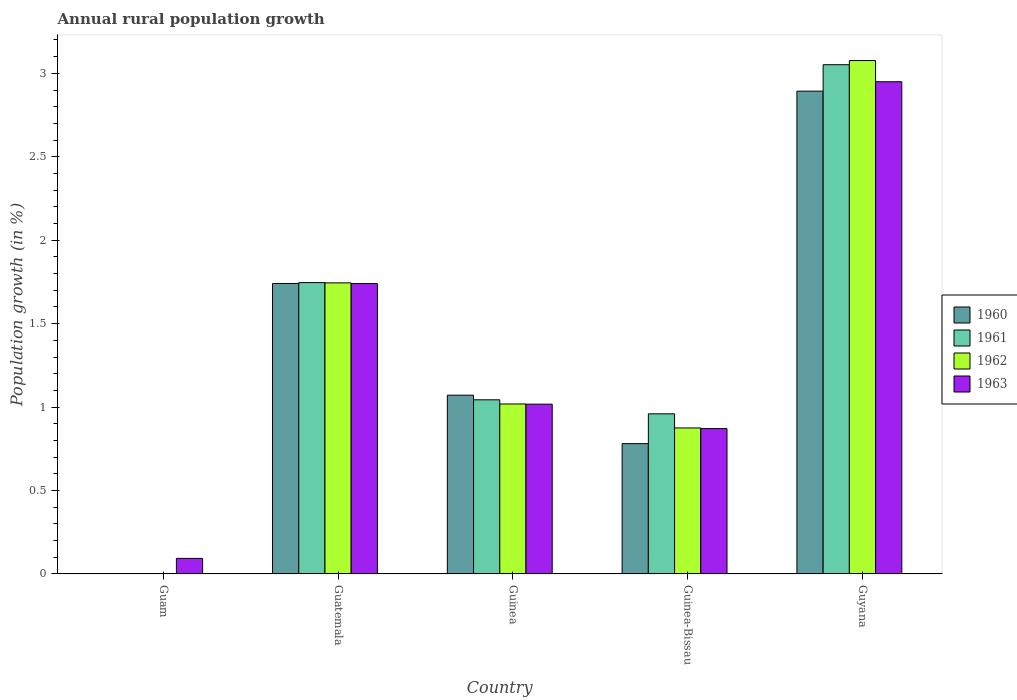How many different coloured bars are there?
Make the answer very short. 4. What is the label of the 5th group of bars from the left?
Your response must be concise. Guyana. In how many cases, is the number of bars for a given country not equal to the number of legend labels?
Provide a short and direct response. 1. What is the percentage of rural population growth in 1962 in Guatemala?
Your response must be concise. 1.74. Across all countries, what is the maximum percentage of rural population growth in 1963?
Provide a succinct answer. 2.95. Across all countries, what is the minimum percentage of rural population growth in 1961?
Your response must be concise. 0. In which country was the percentage of rural population growth in 1963 maximum?
Make the answer very short. Guyana. What is the total percentage of rural population growth in 1963 in the graph?
Give a very brief answer. 6.67. What is the difference between the percentage of rural population growth in 1963 in Guinea and that in Guinea-Bissau?
Offer a very short reply. 0.15. What is the difference between the percentage of rural population growth in 1962 in Guatemala and the percentage of rural population growth in 1961 in Guinea-Bissau?
Ensure brevity in your answer.  0.78. What is the average percentage of rural population growth in 1962 per country?
Provide a succinct answer. 1.34. What is the difference between the percentage of rural population growth of/in 1963 and percentage of rural population growth of/in 1962 in Guatemala?
Offer a very short reply. -0. In how many countries, is the percentage of rural population growth in 1962 greater than 0.2 %?
Ensure brevity in your answer.  4. What is the ratio of the percentage of rural population growth in 1962 in Guinea to that in Guinea-Bissau?
Provide a short and direct response. 1.16. Is the difference between the percentage of rural population growth in 1963 in Guinea-Bissau and Guyana greater than the difference between the percentage of rural population growth in 1962 in Guinea-Bissau and Guyana?
Your response must be concise. Yes. What is the difference between the highest and the second highest percentage of rural population growth in 1961?
Offer a terse response. -1.31. What is the difference between the highest and the lowest percentage of rural population growth in 1960?
Offer a terse response. 2.89. In how many countries, is the percentage of rural population growth in 1960 greater than the average percentage of rural population growth in 1960 taken over all countries?
Give a very brief answer. 2. Is the sum of the percentage of rural population growth in 1963 in Guam and Guatemala greater than the maximum percentage of rural population growth in 1962 across all countries?
Make the answer very short. No. Is it the case that in every country, the sum of the percentage of rural population growth in 1961 and percentage of rural population growth in 1963 is greater than the sum of percentage of rural population growth in 1962 and percentage of rural population growth in 1960?
Your answer should be compact. No. Is it the case that in every country, the sum of the percentage of rural population growth in 1962 and percentage of rural population growth in 1961 is greater than the percentage of rural population growth in 1963?
Offer a terse response. No. How many bars are there?
Your answer should be compact. 17. How many countries are there in the graph?
Provide a short and direct response. 5. What is the difference between two consecutive major ticks on the Y-axis?
Offer a terse response. 0.5. Are the values on the major ticks of Y-axis written in scientific E-notation?
Your answer should be compact. No. Does the graph contain grids?
Ensure brevity in your answer.  No. How many legend labels are there?
Make the answer very short. 4. How are the legend labels stacked?
Make the answer very short. Vertical. What is the title of the graph?
Make the answer very short. Annual rural population growth. Does "1976" appear as one of the legend labels in the graph?
Make the answer very short. No. What is the label or title of the X-axis?
Your answer should be very brief. Country. What is the label or title of the Y-axis?
Provide a short and direct response. Population growth (in %). What is the Population growth (in %) of 1961 in Guam?
Provide a succinct answer. 0. What is the Population growth (in %) of 1962 in Guam?
Provide a short and direct response. 0. What is the Population growth (in %) of 1963 in Guam?
Your answer should be compact. 0.09. What is the Population growth (in %) of 1960 in Guatemala?
Offer a very short reply. 1.74. What is the Population growth (in %) in 1961 in Guatemala?
Provide a succinct answer. 1.75. What is the Population growth (in %) in 1962 in Guatemala?
Your response must be concise. 1.74. What is the Population growth (in %) in 1963 in Guatemala?
Offer a very short reply. 1.74. What is the Population growth (in %) of 1960 in Guinea?
Your answer should be compact. 1.07. What is the Population growth (in %) of 1961 in Guinea?
Offer a terse response. 1.04. What is the Population growth (in %) in 1962 in Guinea?
Your answer should be compact. 1.02. What is the Population growth (in %) of 1963 in Guinea?
Ensure brevity in your answer.  1.02. What is the Population growth (in %) of 1960 in Guinea-Bissau?
Your response must be concise. 0.78. What is the Population growth (in %) of 1961 in Guinea-Bissau?
Provide a short and direct response. 0.96. What is the Population growth (in %) of 1962 in Guinea-Bissau?
Offer a terse response. 0.88. What is the Population growth (in %) of 1963 in Guinea-Bissau?
Give a very brief answer. 0.87. What is the Population growth (in %) of 1960 in Guyana?
Ensure brevity in your answer.  2.89. What is the Population growth (in %) in 1961 in Guyana?
Make the answer very short. 3.05. What is the Population growth (in %) in 1962 in Guyana?
Keep it short and to the point. 3.08. What is the Population growth (in %) in 1963 in Guyana?
Your response must be concise. 2.95. Across all countries, what is the maximum Population growth (in %) in 1960?
Keep it short and to the point. 2.89. Across all countries, what is the maximum Population growth (in %) of 1961?
Provide a short and direct response. 3.05. Across all countries, what is the maximum Population growth (in %) of 1962?
Your answer should be very brief. 3.08. Across all countries, what is the maximum Population growth (in %) of 1963?
Your answer should be very brief. 2.95. Across all countries, what is the minimum Population growth (in %) in 1960?
Provide a succinct answer. 0. Across all countries, what is the minimum Population growth (in %) in 1961?
Provide a succinct answer. 0. Across all countries, what is the minimum Population growth (in %) in 1963?
Offer a very short reply. 0.09. What is the total Population growth (in %) in 1960 in the graph?
Keep it short and to the point. 6.49. What is the total Population growth (in %) of 1961 in the graph?
Provide a short and direct response. 6.8. What is the total Population growth (in %) of 1962 in the graph?
Your answer should be compact. 6.71. What is the total Population growth (in %) in 1963 in the graph?
Provide a succinct answer. 6.67. What is the difference between the Population growth (in %) of 1963 in Guam and that in Guatemala?
Your answer should be compact. -1.65. What is the difference between the Population growth (in %) in 1963 in Guam and that in Guinea?
Offer a very short reply. -0.92. What is the difference between the Population growth (in %) in 1963 in Guam and that in Guinea-Bissau?
Offer a very short reply. -0.78. What is the difference between the Population growth (in %) of 1963 in Guam and that in Guyana?
Give a very brief answer. -2.86. What is the difference between the Population growth (in %) in 1960 in Guatemala and that in Guinea?
Keep it short and to the point. 0.67. What is the difference between the Population growth (in %) of 1961 in Guatemala and that in Guinea?
Offer a very short reply. 0.7. What is the difference between the Population growth (in %) of 1962 in Guatemala and that in Guinea?
Offer a terse response. 0.73. What is the difference between the Population growth (in %) in 1963 in Guatemala and that in Guinea?
Ensure brevity in your answer.  0.72. What is the difference between the Population growth (in %) of 1960 in Guatemala and that in Guinea-Bissau?
Your answer should be compact. 0.96. What is the difference between the Population growth (in %) of 1961 in Guatemala and that in Guinea-Bissau?
Provide a succinct answer. 0.79. What is the difference between the Population growth (in %) in 1962 in Guatemala and that in Guinea-Bissau?
Your response must be concise. 0.87. What is the difference between the Population growth (in %) in 1963 in Guatemala and that in Guinea-Bissau?
Offer a terse response. 0.87. What is the difference between the Population growth (in %) in 1960 in Guatemala and that in Guyana?
Provide a succinct answer. -1.15. What is the difference between the Population growth (in %) of 1961 in Guatemala and that in Guyana?
Keep it short and to the point. -1.31. What is the difference between the Population growth (in %) of 1962 in Guatemala and that in Guyana?
Provide a short and direct response. -1.33. What is the difference between the Population growth (in %) in 1963 in Guatemala and that in Guyana?
Give a very brief answer. -1.21. What is the difference between the Population growth (in %) of 1960 in Guinea and that in Guinea-Bissau?
Offer a terse response. 0.29. What is the difference between the Population growth (in %) in 1961 in Guinea and that in Guinea-Bissau?
Give a very brief answer. 0.08. What is the difference between the Population growth (in %) of 1962 in Guinea and that in Guinea-Bissau?
Keep it short and to the point. 0.14. What is the difference between the Population growth (in %) of 1963 in Guinea and that in Guinea-Bissau?
Provide a succinct answer. 0.15. What is the difference between the Population growth (in %) in 1960 in Guinea and that in Guyana?
Provide a short and direct response. -1.82. What is the difference between the Population growth (in %) in 1961 in Guinea and that in Guyana?
Your answer should be compact. -2.01. What is the difference between the Population growth (in %) of 1962 in Guinea and that in Guyana?
Offer a terse response. -2.06. What is the difference between the Population growth (in %) in 1963 in Guinea and that in Guyana?
Your answer should be compact. -1.93. What is the difference between the Population growth (in %) in 1960 in Guinea-Bissau and that in Guyana?
Provide a succinct answer. -2.11. What is the difference between the Population growth (in %) of 1961 in Guinea-Bissau and that in Guyana?
Offer a terse response. -2.09. What is the difference between the Population growth (in %) in 1962 in Guinea-Bissau and that in Guyana?
Your response must be concise. -2.2. What is the difference between the Population growth (in %) of 1963 in Guinea-Bissau and that in Guyana?
Offer a terse response. -2.08. What is the difference between the Population growth (in %) in 1960 in Guatemala and the Population growth (in %) in 1961 in Guinea?
Keep it short and to the point. 0.7. What is the difference between the Population growth (in %) of 1960 in Guatemala and the Population growth (in %) of 1962 in Guinea?
Provide a succinct answer. 0.72. What is the difference between the Population growth (in %) in 1960 in Guatemala and the Population growth (in %) in 1963 in Guinea?
Make the answer very short. 0.72. What is the difference between the Population growth (in %) in 1961 in Guatemala and the Population growth (in %) in 1962 in Guinea?
Your answer should be very brief. 0.73. What is the difference between the Population growth (in %) in 1961 in Guatemala and the Population growth (in %) in 1963 in Guinea?
Offer a terse response. 0.73. What is the difference between the Population growth (in %) of 1962 in Guatemala and the Population growth (in %) of 1963 in Guinea?
Your answer should be very brief. 0.73. What is the difference between the Population growth (in %) in 1960 in Guatemala and the Population growth (in %) in 1961 in Guinea-Bissau?
Offer a very short reply. 0.78. What is the difference between the Population growth (in %) in 1960 in Guatemala and the Population growth (in %) in 1962 in Guinea-Bissau?
Offer a very short reply. 0.87. What is the difference between the Population growth (in %) of 1960 in Guatemala and the Population growth (in %) of 1963 in Guinea-Bissau?
Offer a very short reply. 0.87. What is the difference between the Population growth (in %) of 1961 in Guatemala and the Population growth (in %) of 1962 in Guinea-Bissau?
Provide a short and direct response. 0.87. What is the difference between the Population growth (in %) in 1961 in Guatemala and the Population growth (in %) in 1963 in Guinea-Bissau?
Offer a very short reply. 0.87. What is the difference between the Population growth (in %) in 1962 in Guatemala and the Population growth (in %) in 1963 in Guinea-Bissau?
Offer a terse response. 0.87. What is the difference between the Population growth (in %) in 1960 in Guatemala and the Population growth (in %) in 1961 in Guyana?
Offer a very short reply. -1.31. What is the difference between the Population growth (in %) in 1960 in Guatemala and the Population growth (in %) in 1962 in Guyana?
Offer a terse response. -1.34. What is the difference between the Population growth (in %) of 1960 in Guatemala and the Population growth (in %) of 1963 in Guyana?
Provide a succinct answer. -1.21. What is the difference between the Population growth (in %) in 1961 in Guatemala and the Population growth (in %) in 1962 in Guyana?
Your answer should be compact. -1.33. What is the difference between the Population growth (in %) in 1961 in Guatemala and the Population growth (in %) in 1963 in Guyana?
Give a very brief answer. -1.2. What is the difference between the Population growth (in %) of 1962 in Guatemala and the Population growth (in %) of 1963 in Guyana?
Provide a short and direct response. -1.21. What is the difference between the Population growth (in %) of 1960 in Guinea and the Population growth (in %) of 1961 in Guinea-Bissau?
Your answer should be compact. 0.11. What is the difference between the Population growth (in %) of 1960 in Guinea and the Population growth (in %) of 1962 in Guinea-Bissau?
Your answer should be very brief. 0.2. What is the difference between the Population growth (in %) of 1960 in Guinea and the Population growth (in %) of 1963 in Guinea-Bissau?
Offer a terse response. 0.2. What is the difference between the Population growth (in %) of 1961 in Guinea and the Population growth (in %) of 1962 in Guinea-Bissau?
Your response must be concise. 0.17. What is the difference between the Population growth (in %) in 1961 in Guinea and the Population growth (in %) in 1963 in Guinea-Bissau?
Provide a succinct answer. 0.17. What is the difference between the Population growth (in %) in 1962 in Guinea and the Population growth (in %) in 1963 in Guinea-Bissau?
Provide a succinct answer. 0.15. What is the difference between the Population growth (in %) of 1960 in Guinea and the Population growth (in %) of 1961 in Guyana?
Offer a very short reply. -1.98. What is the difference between the Population growth (in %) of 1960 in Guinea and the Population growth (in %) of 1962 in Guyana?
Ensure brevity in your answer.  -2.01. What is the difference between the Population growth (in %) of 1960 in Guinea and the Population growth (in %) of 1963 in Guyana?
Make the answer very short. -1.88. What is the difference between the Population growth (in %) in 1961 in Guinea and the Population growth (in %) in 1962 in Guyana?
Your response must be concise. -2.03. What is the difference between the Population growth (in %) of 1961 in Guinea and the Population growth (in %) of 1963 in Guyana?
Your answer should be compact. -1.91. What is the difference between the Population growth (in %) in 1962 in Guinea and the Population growth (in %) in 1963 in Guyana?
Provide a short and direct response. -1.93. What is the difference between the Population growth (in %) in 1960 in Guinea-Bissau and the Population growth (in %) in 1961 in Guyana?
Keep it short and to the point. -2.27. What is the difference between the Population growth (in %) in 1960 in Guinea-Bissau and the Population growth (in %) in 1962 in Guyana?
Offer a very short reply. -2.3. What is the difference between the Population growth (in %) of 1960 in Guinea-Bissau and the Population growth (in %) of 1963 in Guyana?
Provide a short and direct response. -2.17. What is the difference between the Population growth (in %) of 1961 in Guinea-Bissau and the Population growth (in %) of 1962 in Guyana?
Make the answer very short. -2.12. What is the difference between the Population growth (in %) of 1961 in Guinea-Bissau and the Population growth (in %) of 1963 in Guyana?
Your answer should be compact. -1.99. What is the difference between the Population growth (in %) in 1962 in Guinea-Bissau and the Population growth (in %) in 1963 in Guyana?
Ensure brevity in your answer.  -2.07. What is the average Population growth (in %) of 1960 per country?
Keep it short and to the point. 1.3. What is the average Population growth (in %) of 1961 per country?
Keep it short and to the point. 1.36. What is the average Population growth (in %) in 1962 per country?
Give a very brief answer. 1.34. What is the average Population growth (in %) in 1963 per country?
Your response must be concise. 1.33. What is the difference between the Population growth (in %) in 1960 and Population growth (in %) in 1961 in Guatemala?
Make the answer very short. -0.01. What is the difference between the Population growth (in %) in 1960 and Population growth (in %) in 1962 in Guatemala?
Your answer should be compact. -0. What is the difference between the Population growth (in %) of 1960 and Population growth (in %) of 1963 in Guatemala?
Give a very brief answer. 0. What is the difference between the Population growth (in %) of 1961 and Population growth (in %) of 1962 in Guatemala?
Your answer should be very brief. 0. What is the difference between the Population growth (in %) in 1961 and Population growth (in %) in 1963 in Guatemala?
Your answer should be compact. 0.01. What is the difference between the Population growth (in %) of 1962 and Population growth (in %) of 1963 in Guatemala?
Offer a very short reply. 0. What is the difference between the Population growth (in %) in 1960 and Population growth (in %) in 1961 in Guinea?
Offer a very short reply. 0.03. What is the difference between the Population growth (in %) of 1960 and Population growth (in %) of 1962 in Guinea?
Provide a short and direct response. 0.05. What is the difference between the Population growth (in %) of 1960 and Population growth (in %) of 1963 in Guinea?
Ensure brevity in your answer.  0.05. What is the difference between the Population growth (in %) in 1961 and Population growth (in %) in 1962 in Guinea?
Ensure brevity in your answer.  0.03. What is the difference between the Population growth (in %) in 1961 and Population growth (in %) in 1963 in Guinea?
Ensure brevity in your answer.  0.03. What is the difference between the Population growth (in %) in 1962 and Population growth (in %) in 1963 in Guinea?
Keep it short and to the point. 0. What is the difference between the Population growth (in %) of 1960 and Population growth (in %) of 1961 in Guinea-Bissau?
Offer a terse response. -0.18. What is the difference between the Population growth (in %) of 1960 and Population growth (in %) of 1962 in Guinea-Bissau?
Offer a terse response. -0.09. What is the difference between the Population growth (in %) in 1960 and Population growth (in %) in 1963 in Guinea-Bissau?
Provide a short and direct response. -0.09. What is the difference between the Population growth (in %) in 1961 and Population growth (in %) in 1962 in Guinea-Bissau?
Keep it short and to the point. 0.08. What is the difference between the Population growth (in %) in 1961 and Population growth (in %) in 1963 in Guinea-Bissau?
Make the answer very short. 0.09. What is the difference between the Population growth (in %) in 1962 and Population growth (in %) in 1963 in Guinea-Bissau?
Make the answer very short. 0. What is the difference between the Population growth (in %) in 1960 and Population growth (in %) in 1961 in Guyana?
Ensure brevity in your answer.  -0.16. What is the difference between the Population growth (in %) of 1960 and Population growth (in %) of 1962 in Guyana?
Ensure brevity in your answer.  -0.18. What is the difference between the Population growth (in %) of 1960 and Population growth (in %) of 1963 in Guyana?
Make the answer very short. -0.06. What is the difference between the Population growth (in %) of 1961 and Population growth (in %) of 1962 in Guyana?
Your answer should be very brief. -0.03. What is the difference between the Population growth (in %) in 1961 and Population growth (in %) in 1963 in Guyana?
Your answer should be compact. 0.1. What is the difference between the Population growth (in %) in 1962 and Population growth (in %) in 1963 in Guyana?
Make the answer very short. 0.13. What is the ratio of the Population growth (in %) of 1963 in Guam to that in Guatemala?
Provide a succinct answer. 0.05. What is the ratio of the Population growth (in %) of 1963 in Guam to that in Guinea?
Offer a very short reply. 0.09. What is the ratio of the Population growth (in %) of 1963 in Guam to that in Guinea-Bissau?
Provide a short and direct response. 0.11. What is the ratio of the Population growth (in %) of 1963 in Guam to that in Guyana?
Give a very brief answer. 0.03. What is the ratio of the Population growth (in %) in 1960 in Guatemala to that in Guinea?
Your answer should be compact. 1.62. What is the ratio of the Population growth (in %) of 1961 in Guatemala to that in Guinea?
Your answer should be compact. 1.67. What is the ratio of the Population growth (in %) of 1962 in Guatemala to that in Guinea?
Make the answer very short. 1.71. What is the ratio of the Population growth (in %) in 1963 in Guatemala to that in Guinea?
Your answer should be very brief. 1.71. What is the ratio of the Population growth (in %) in 1960 in Guatemala to that in Guinea-Bissau?
Ensure brevity in your answer.  2.23. What is the ratio of the Population growth (in %) in 1961 in Guatemala to that in Guinea-Bissau?
Your answer should be very brief. 1.82. What is the ratio of the Population growth (in %) in 1962 in Guatemala to that in Guinea-Bissau?
Give a very brief answer. 1.99. What is the ratio of the Population growth (in %) in 1963 in Guatemala to that in Guinea-Bissau?
Ensure brevity in your answer.  2. What is the ratio of the Population growth (in %) of 1960 in Guatemala to that in Guyana?
Your response must be concise. 0.6. What is the ratio of the Population growth (in %) of 1961 in Guatemala to that in Guyana?
Your response must be concise. 0.57. What is the ratio of the Population growth (in %) of 1962 in Guatemala to that in Guyana?
Your answer should be very brief. 0.57. What is the ratio of the Population growth (in %) in 1963 in Guatemala to that in Guyana?
Offer a very short reply. 0.59. What is the ratio of the Population growth (in %) in 1960 in Guinea to that in Guinea-Bissau?
Provide a succinct answer. 1.37. What is the ratio of the Population growth (in %) of 1961 in Guinea to that in Guinea-Bissau?
Your answer should be very brief. 1.09. What is the ratio of the Population growth (in %) in 1962 in Guinea to that in Guinea-Bissau?
Ensure brevity in your answer.  1.16. What is the ratio of the Population growth (in %) in 1963 in Guinea to that in Guinea-Bissau?
Provide a short and direct response. 1.17. What is the ratio of the Population growth (in %) of 1960 in Guinea to that in Guyana?
Your answer should be compact. 0.37. What is the ratio of the Population growth (in %) in 1961 in Guinea to that in Guyana?
Your answer should be very brief. 0.34. What is the ratio of the Population growth (in %) in 1962 in Guinea to that in Guyana?
Your answer should be compact. 0.33. What is the ratio of the Population growth (in %) in 1963 in Guinea to that in Guyana?
Give a very brief answer. 0.34. What is the ratio of the Population growth (in %) in 1960 in Guinea-Bissau to that in Guyana?
Provide a short and direct response. 0.27. What is the ratio of the Population growth (in %) of 1961 in Guinea-Bissau to that in Guyana?
Your response must be concise. 0.31. What is the ratio of the Population growth (in %) in 1962 in Guinea-Bissau to that in Guyana?
Make the answer very short. 0.28. What is the ratio of the Population growth (in %) in 1963 in Guinea-Bissau to that in Guyana?
Keep it short and to the point. 0.3. What is the difference between the highest and the second highest Population growth (in %) in 1960?
Offer a very short reply. 1.15. What is the difference between the highest and the second highest Population growth (in %) of 1961?
Offer a very short reply. 1.31. What is the difference between the highest and the second highest Population growth (in %) of 1962?
Your answer should be compact. 1.33. What is the difference between the highest and the second highest Population growth (in %) of 1963?
Offer a terse response. 1.21. What is the difference between the highest and the lowest Population growth (in %) of 1960?
Ensure brevity in your answer.  2.89. What is the difference between the highest and the lowest Population growth (in %) of 1961?
Your answer should be compact. 3.05. What is the difference between the highest and the lowest Population growth (in %) of 1962?
Give a very brief answer. 3.08. What is the difference between the highest and the lowest Population growth (in %) in 1963?
Your response must be concise. 2.86. 